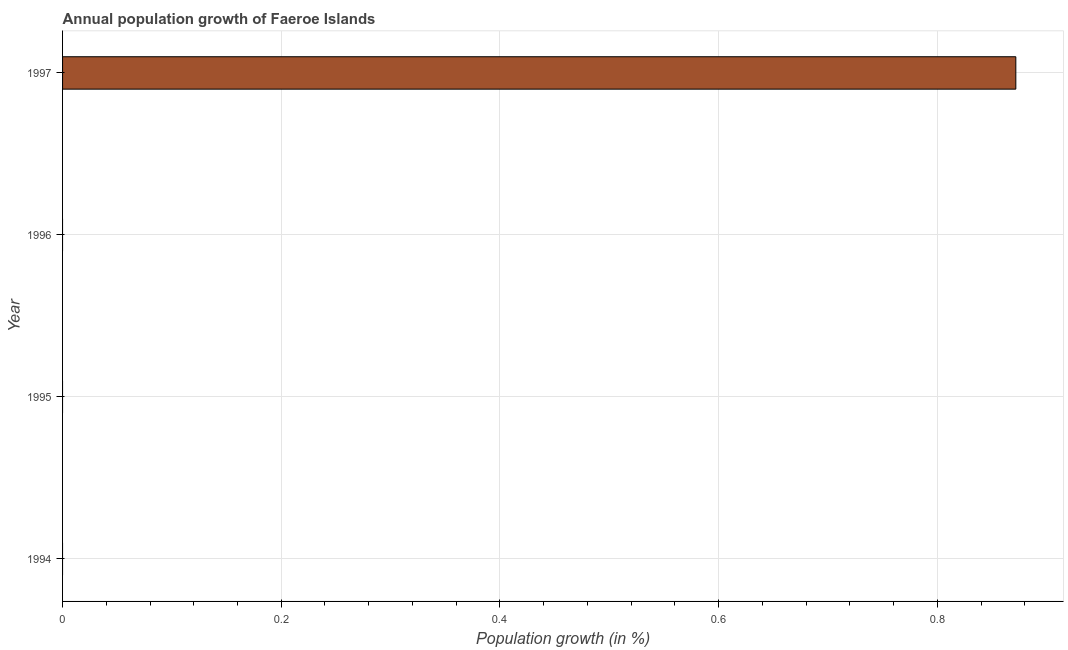Does the graph contain any zero values?
Your response must be concise. Yes. Does the graph contain grids?
Offer a terse response. Yes. What is the title of the graph?
Provide a succinct answer. Annual population growth of Faeroe Islands. What is the label or title of the X-axis?
Your response must be concise. Population growth (in %). What is the population growth in 1995?
Make the answer very short. 0. Across all years, what is the maximum population growth?
Ensure brevity in your answer.  0.87. In which year was the population growth maximum?
Your answer should be compact. 1997. What is the sum of the population growth?
Offer a terse response. 0.87. What is the average population growth per year?
Provide a succinct answer. 0.22. What is the median population growth?
Give a very brief answer. 0. What is the difference between the highest and the lowest population growth?
Your answer should be very brief. 0.87. In how many years, is the population growth greater than the average population growth taken over all years?
Give a very brief answer. 1. Are all the bars in the graph horizontal?
Your response must be concise. Yes. How many years are there in the graph?
Offer a terse response. 4. What is the Population growth (in %) of 1997?
Give a very brief answer. 0.87. 